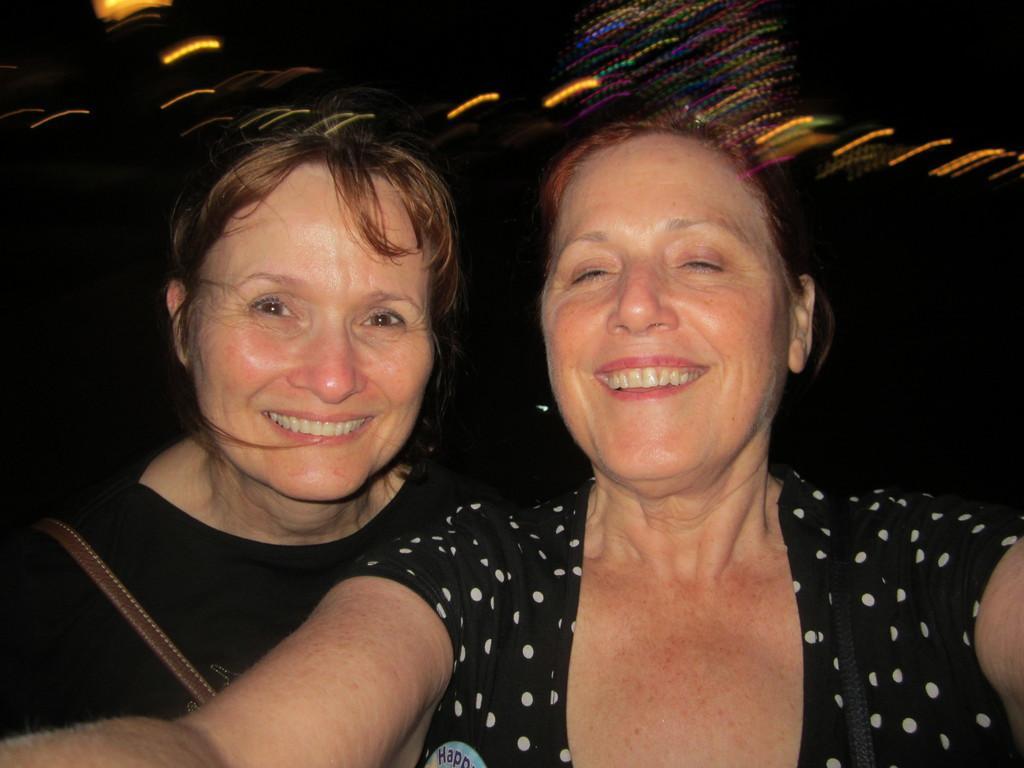Please provide a concise description of this image. In this image we can see two women are smiling. There is a dark background and we can see lights. 